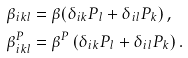Convert formula to latex. <formula><loc_0><loc_0><loc_500><loc_500>\beta _ { i k l } & = \beta ( \delta _ { i k } P _ { l } + \delta _ { i l } P _ { k } ) \, , \\ \beta ^ { P } _ { i k l } & = \beta ^ { P } \, ( \delta _ { i k } P _ { l } + \delta _ { i l } P _ { k } ) \, .</formula> 